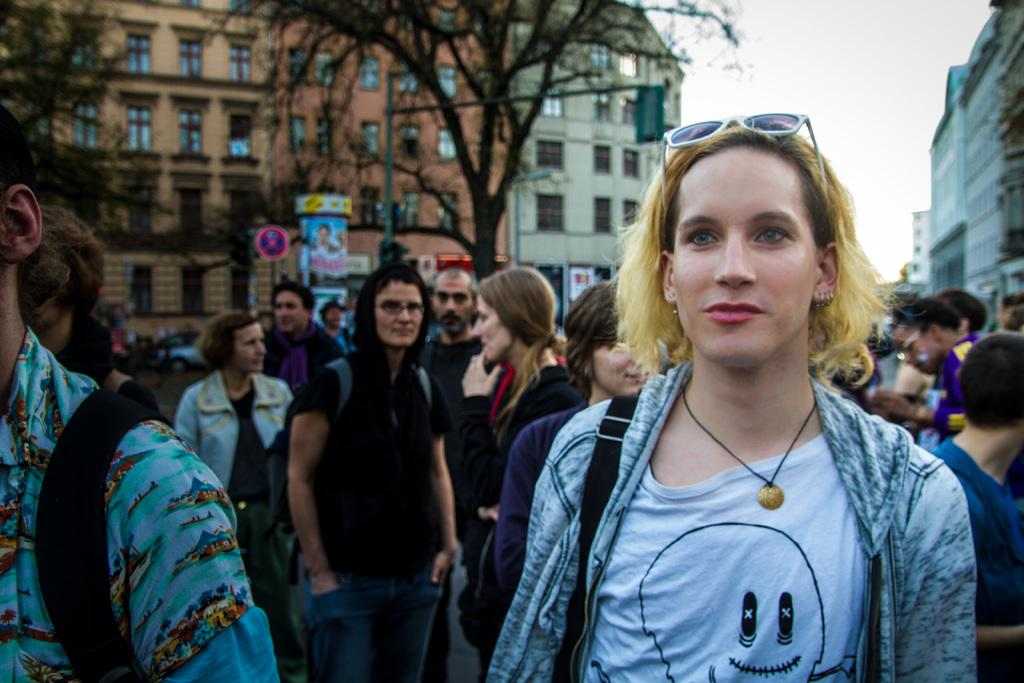Who is the main subject in the image? There is a woman in the image. What is the woman doing in the image? The woman is smiling. Can you describe the group of people in the image? There is a group of people in the image. What can be seen on the walls in the image? There are posters in the image. What type of vegetation is visible in the image? There are trees in the image. What type of structures are visible in the image? There are buildings with windows in the image. What other objects can be seen in the image? There are some objects in the image. What is visible in the background of the image? The sky is visible in the background of the image. What is the woman's name in the image? The provided facts do not mention the name of the woman in the image. How does the woman achieve peace in the image? The provided facts do not mention any actions related to achieving peace in the image. 